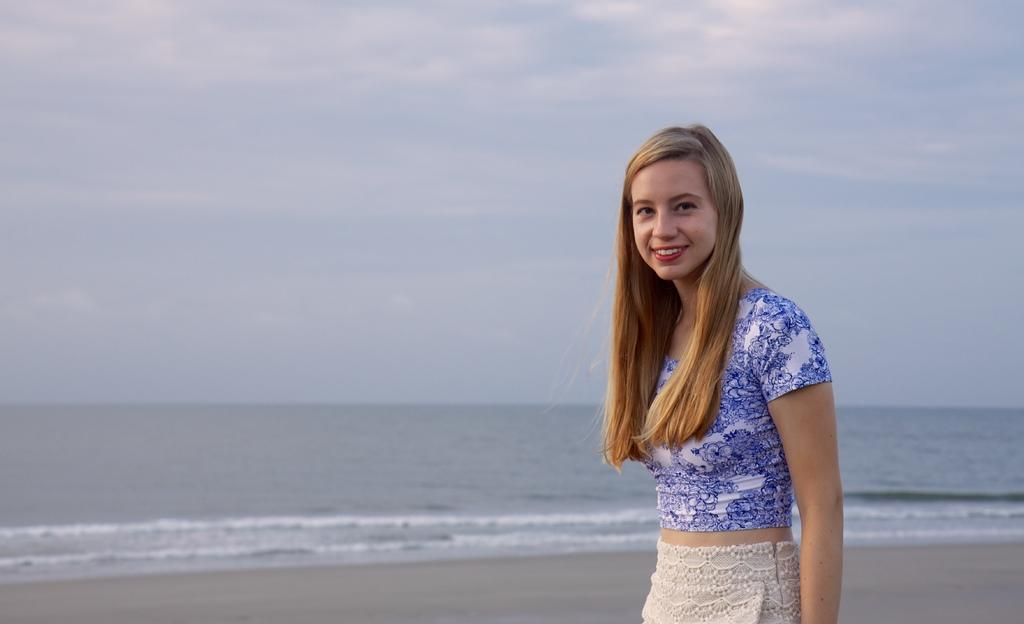Who is the main subject in the picture? There is a girl in the picture. What is the girl's expression in the image? The girl is smiling. What can be seen in the background of the image? Water and the sky are visible in the background of the image. What is the condition of the sky in the image? Clouds are present in the sky. What type of winter clothing is the girl wearing in the image? There is no mention of winter or winter clothing in the image, as it does not appear to be a winter scene. 